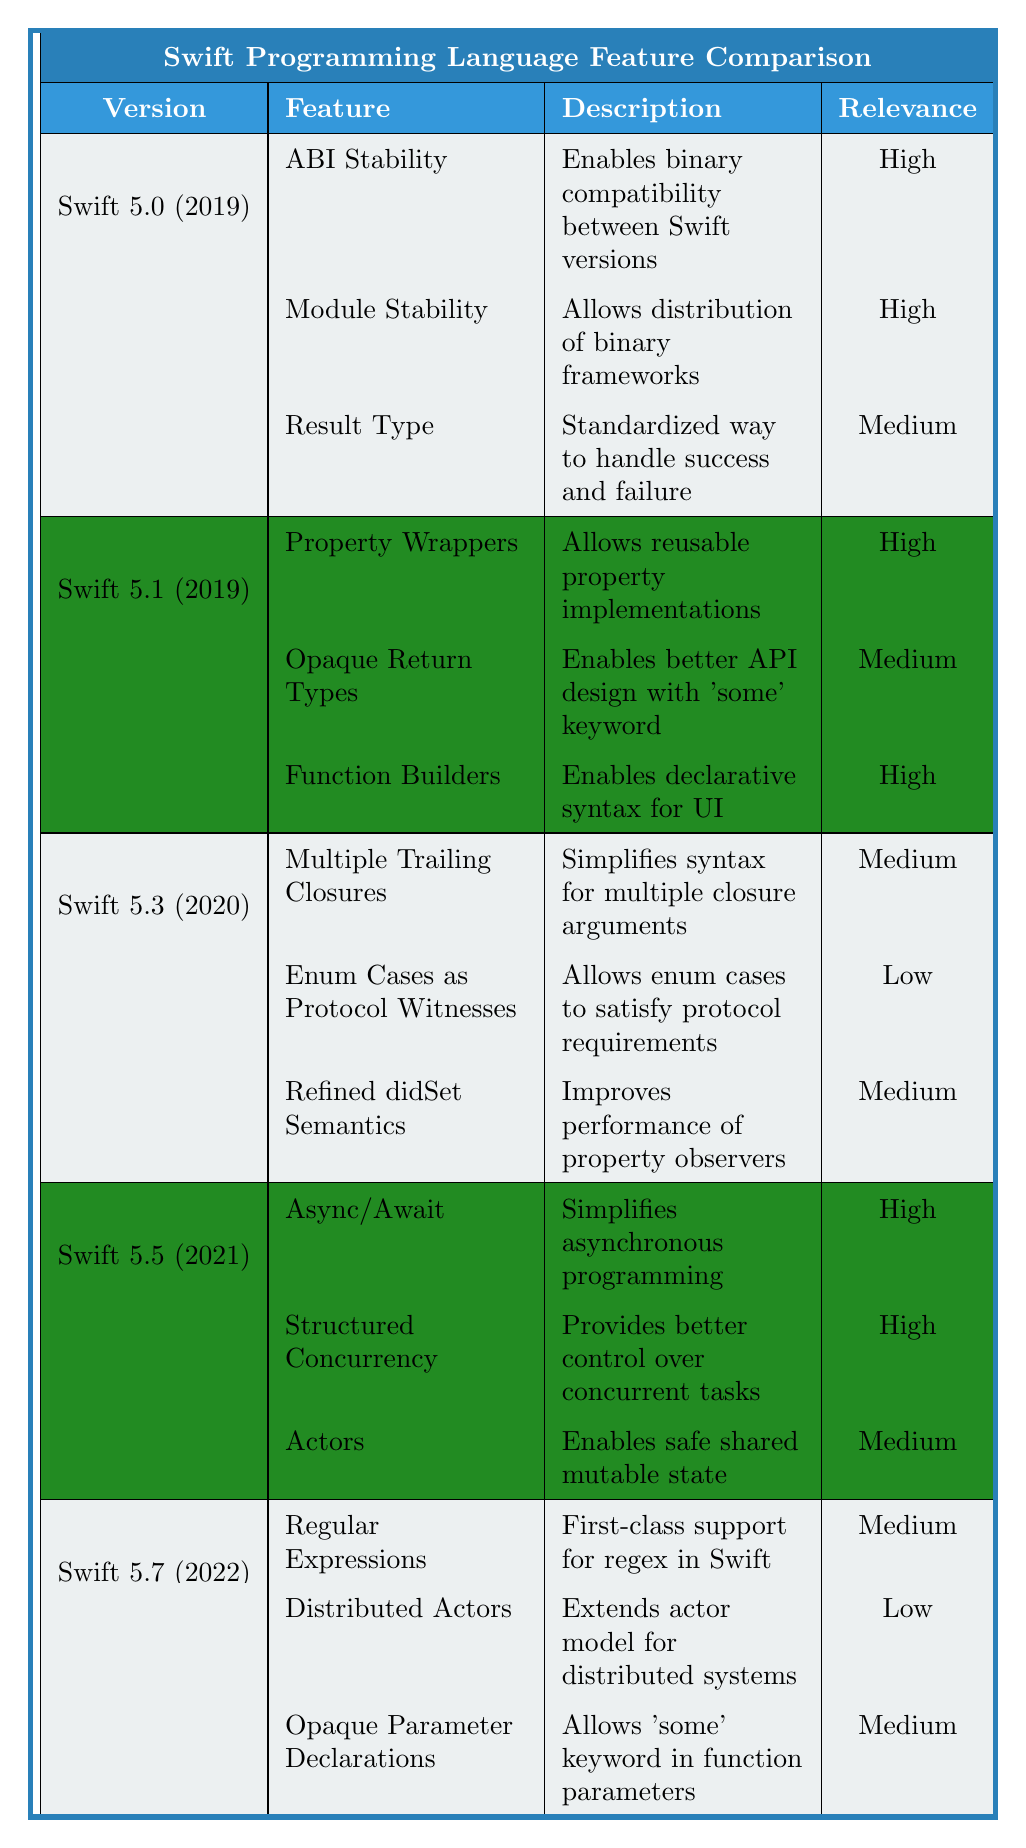What version introduced ABI Stability? According to the table, ABI Stability was introduced in Swift 5.0, which was released in 2019.
Answer: Swift 5.0 Which version was released in the same year as Property Wrappers? Property Wrappers were introduced in Swift 5.1. Since both versions 5.0 and 5.1 are in 2019, we note that Property Wrappers were part of 5.1 specifically.
Answer: Swift 5.1 How many major features were introduced in Swift 5.5? The table indicates that three major features were introduced in Swift 5.5.
Answer: 3 Is the Relevance of "Actors" in Swift 5.5 considered High? The table lists the Relevance for "Actors" as Medium in Swift 5.5, which means it is not High.
Answer: No Which version had the lowest relevance for any feature, and what was that feature? Looking through the table, "Enum Cases as Protocol Witnesses" in Swift 5.3 has the lowest relevance, categorized as Low.
Answer: Swift 5.3, Enum Cases as Protocol Witnesses What is the average relevance rating for features in Swift 5.0? Swift 5.0 has three features with relevance ratings of High, High, and Medium. Assigning numerical values (High=3, Medium=2), the average relevance is (3 + 3 + 2) / 3 = 8 / 3 ≈ 2.67 or roughly Medium.
Answer: Medium What feature in Swift 5.7 is focused on Regex support? The feature focused on regex support in Swift 5.7 is "Regular Expressions," described as first-class support for regex in Swift.
Answer: Regular Expressions Which Swift version introduced Async/Await, and why is it significant? Async/Await was introduced in Swift 5.5. Its significance lies in simplifying asynchronous programming, which is vital for modern app development, especially for iOS applications that rely heavily on asynchronous operations.
Answer: Swift 5.5, significant for simplifying asynchronous programming 